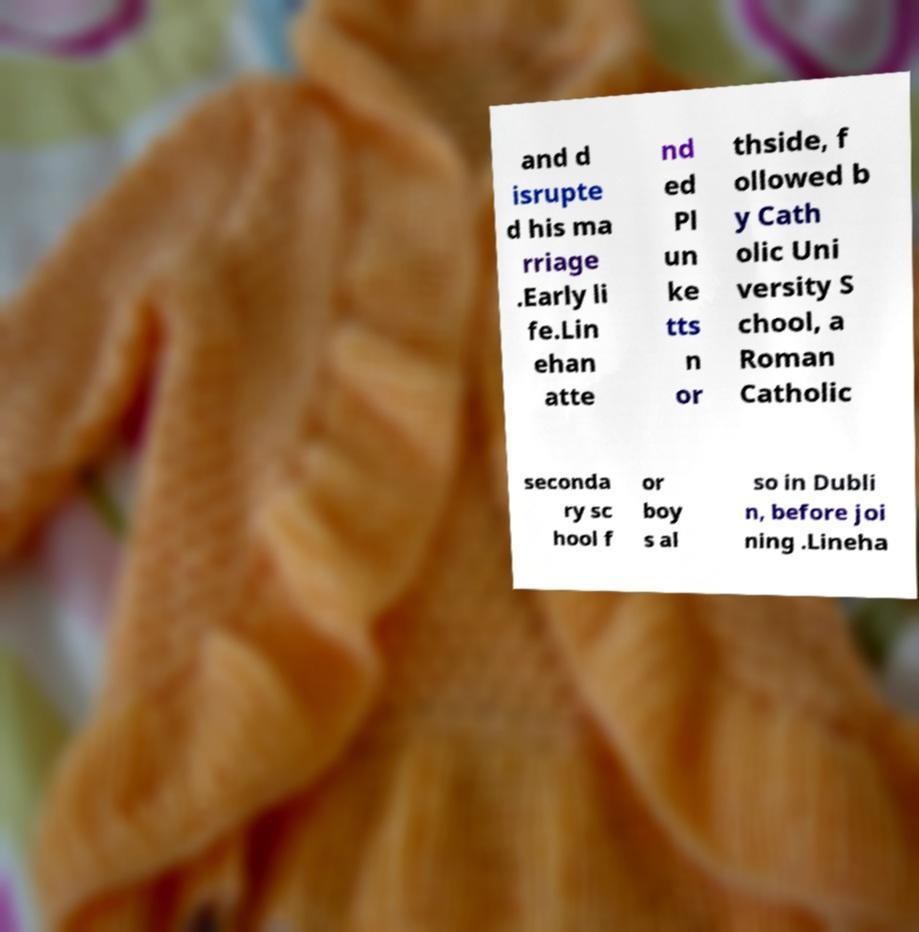There's text embedded in this image that I need extracted. Can you transcribe it verbatim? and d isrupte d his ma rriage .Early li fe.Lin ehan atte nd ed Pl un ke tts n or thside, f ollowed b y Cath olic Uni versity S chool, a Roman Catholic seconda ry sc hool f or boy s al so in Dubli n, before joi ning .Lineha 